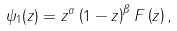Convert formula to latex. <formula><loc_0><loc_0><loc_500><loc_500>\psi _ { 1 } ( z ) = z ^ { \alpha } \left ( 1 - z \right ) ^ { \beta } F \left ( z \right ) ,</formula> 